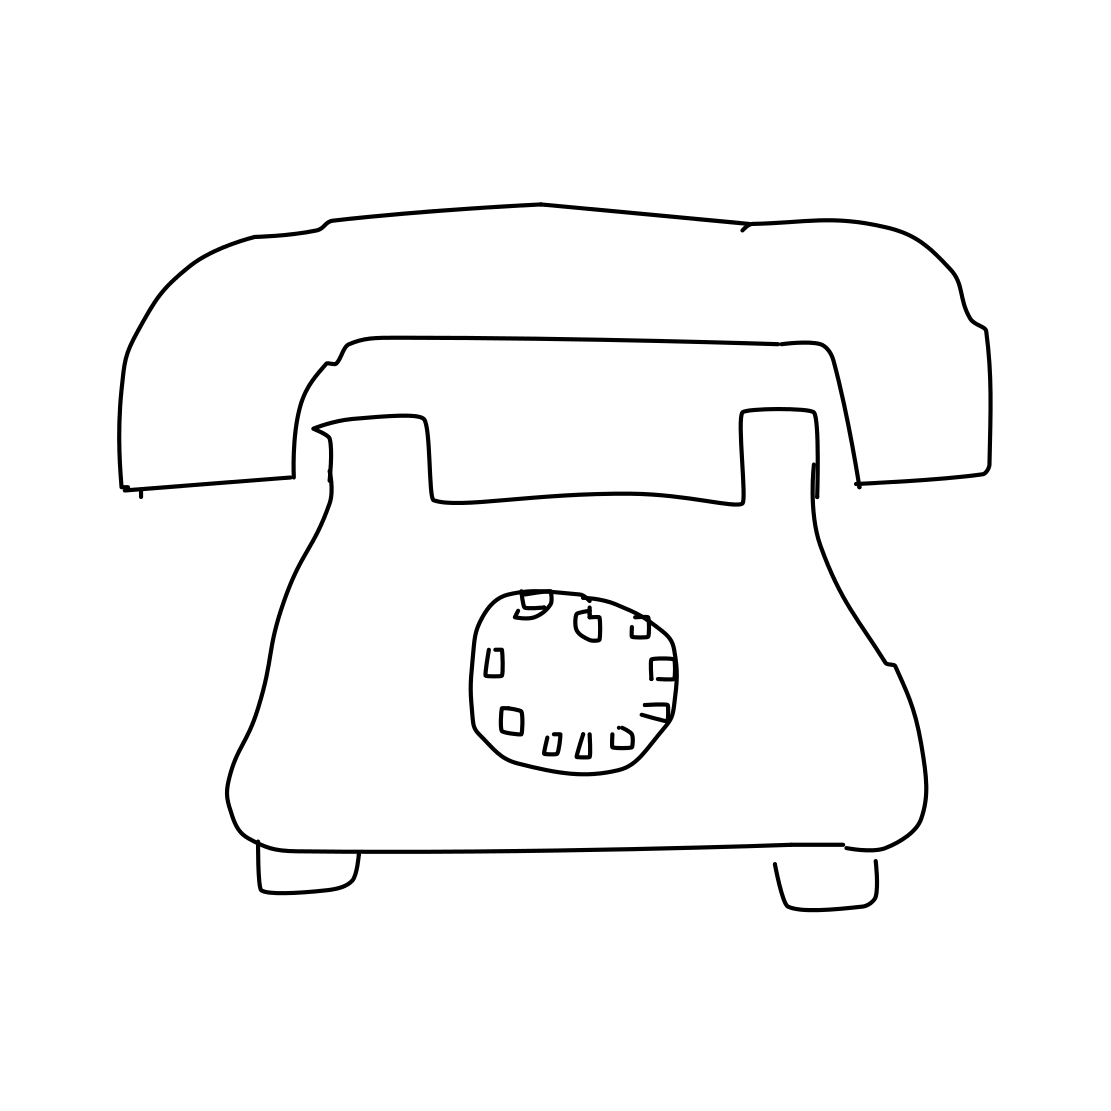Is this a tv in the image? No, it is not a TV; the image depicts a drawing of an old-fashioned rotary telephone, characterized by its distinct handset and circular dial. 